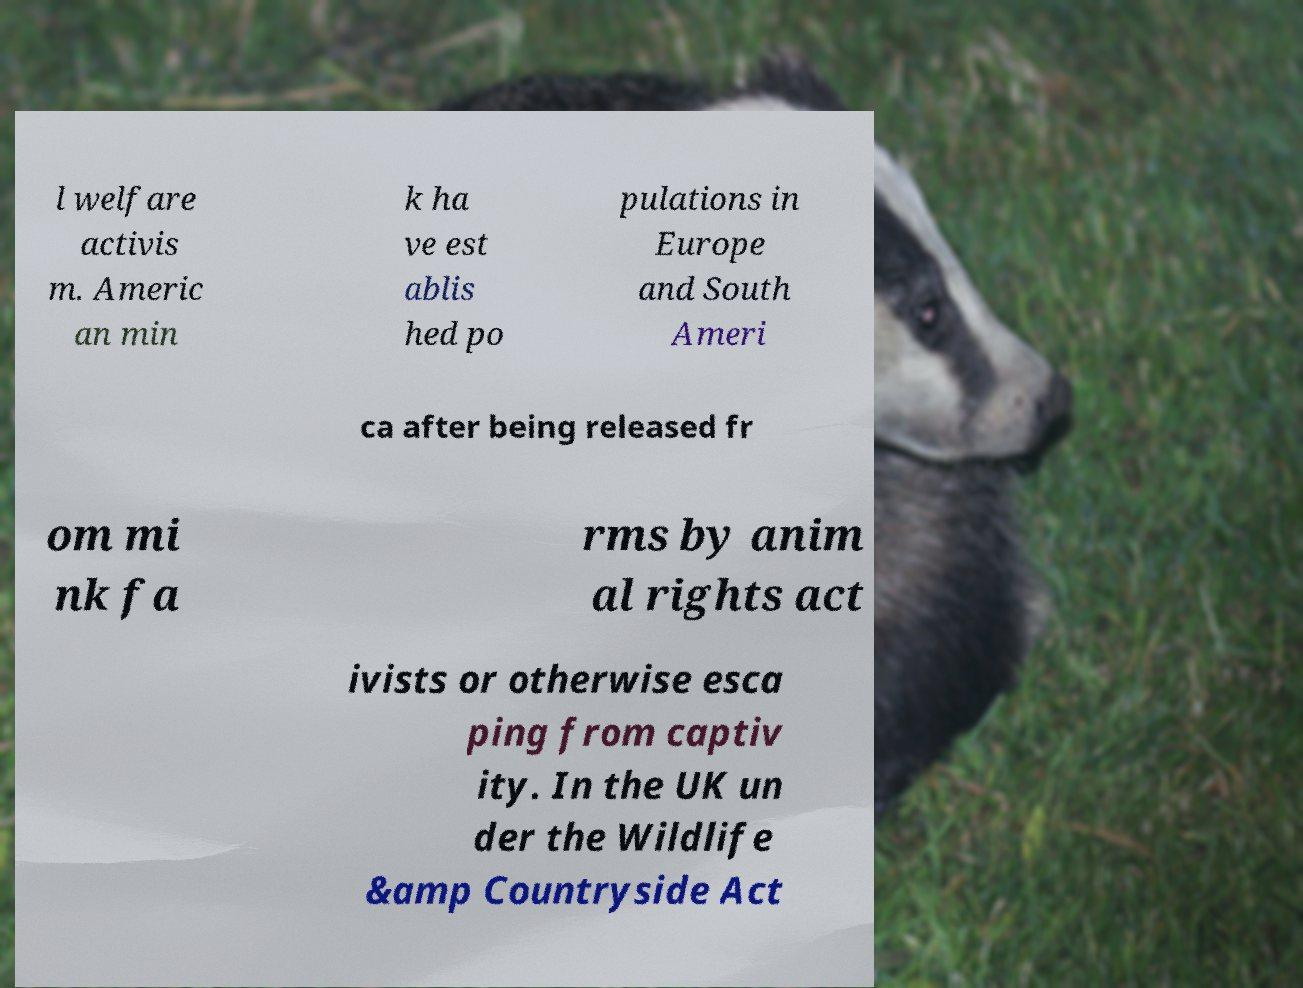Could you extract and type out the text from this image? l welfare activis m. Americ an min k ha ve est ablis hed po pulations in Europe and South Ameri ca after being released fr om mi nk fa rms by anim al rights act ivists or otherwise esca ping from captiv ity. In the UK un der the Wildlife &amp Countryside Act 